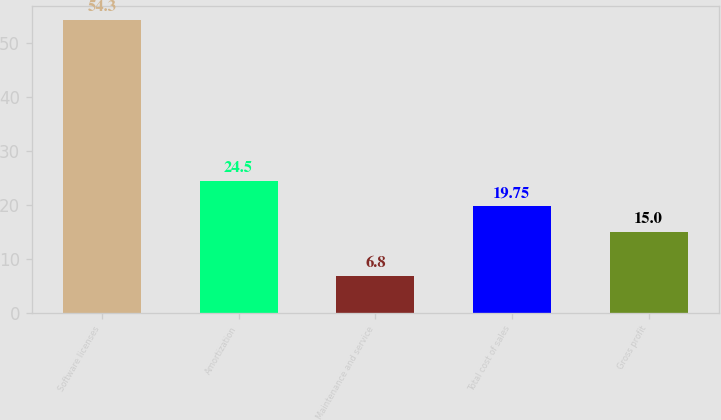Convert chart to OTSL. <chart><loc_0><loc_0><loc_500><loc_500><bar_chart><fcel>Software licenses<fcel>Amortization<fcel>Maintenance and service<fcel>Total cost of sales<fcel>Gross profit<nl><fcel>54.3<fcel>24.5<fcel>6.8<fcel>19.75<fcel>15<nl></chart> 